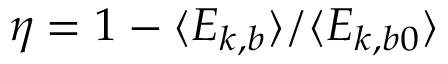<formula> <loc_0><loc_0><loc_500><loc_500>\eta = 1 - \langle E _ { k , b } \rangle / \langle E _ { k , b 0 } \rangle</formula> 